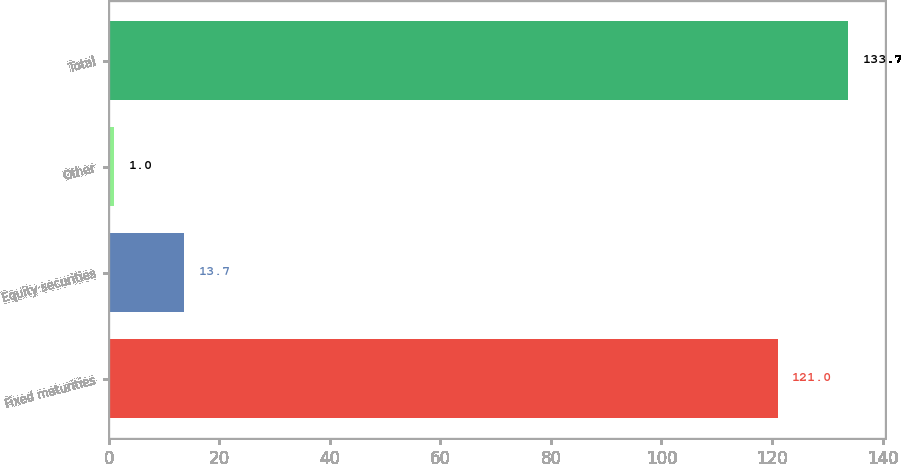Convert chart. <chart><loc_0><loc_0><loc_500><loc_500><bar_chart><fcel>Fixed maturities<fcel>Equity securities<fcel>Other<fcel>Total<nl><fcel>121<fcel>13.7<fcel>1<fcel>133.7<nl></chart> 